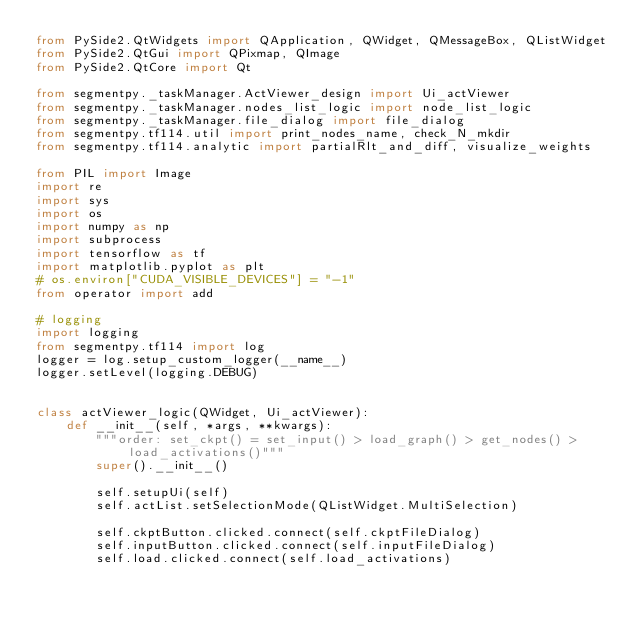Convert code to text. <code><loc_0><loc_0><loc_500><loc_500><_Python_>from PySide2.QtWidgets import QApplication, QWidget, QMessageBox, QListWidget
from PySide2.QtGui import QPixmap, QImage
from PySide2.QtCore import Qt

from segmentpy._taskManager.ActViewer_design import Ui_actViewer
from segmentpy._taskManager.nodes_list_logic import node_list_logic
from segmentpy._taskManager.file_dialog import file_dialog
from segmentpy.tf114.util import print_nodes_name, check_N_mkdir
from segmentpy.tf114.analytic import partialRlt_and_diff, visualize_weights

from PIL import Image
import re
import sys
import os
import numpy as np
import subprocess
import tensorflow as tf
import matplotlib.pyplot as plt
# os.environ["CUDA_VISIBLE_DEVICES"] = "-1"
from operator import add

# logging
import logging
from segmentpy.tf114 import log
logger = log.setup_custom_logger(__name__)
logger.setLevel(logging.DEBUG)


class actViewer_logic(QWidget, Ui_actViewer):
    def __init__(self, *args, **kwargs):
        """order: set_ckpt() = set_input() > load_graph() > get_nodes() > load_activations()"""
        super().__init__()

        self.setupUi(self)
        self.actList.setSelectionMode(QListWidget.MultiSelection)

        self.ckptButton.clicked.connect(self.ckptFileDialog)
        self.inputButton.clicked.connect(self.inputFileDialog)
        self.load.clicked.connect(self.load_activations)</code> 